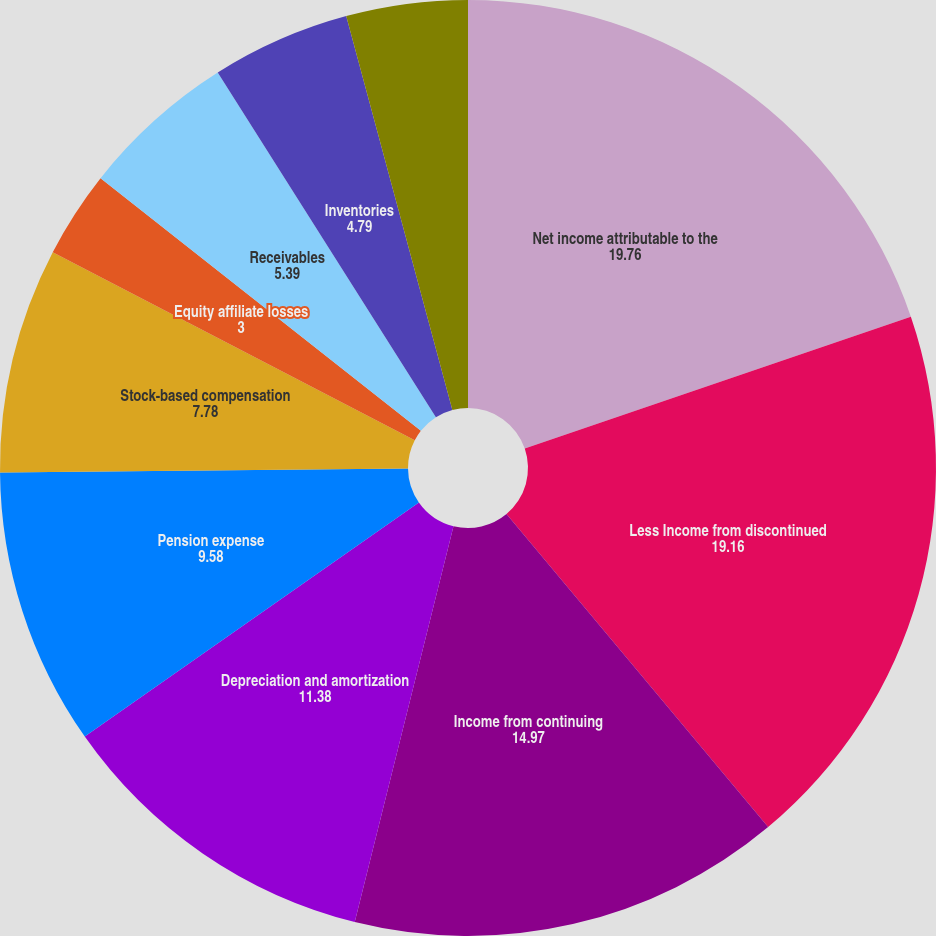Convert chart. <chart><loc_0><loc_0><loc_500><loc_500><pie_chart><fcel>Net income attributable to the<fcel>Less Income from discontinued<fcel>Income from continuing<fcel>Depreciation and amortization<fcel>Pension expense<fcel>Stock-based compensation<fcel>Equity affiliate losses<fcel>Receivables<fcel>Inventories<fcel>Other current assets<nl><fcel>19.76%<fcel>19.16%<fcel>14.97%<fcel>11.38%<fcel>9.58%<fcel>7.78%<fcel>3.0%<fcel>5.39%<fcel>4.79%<fcel>4.19%<nl></chart> 